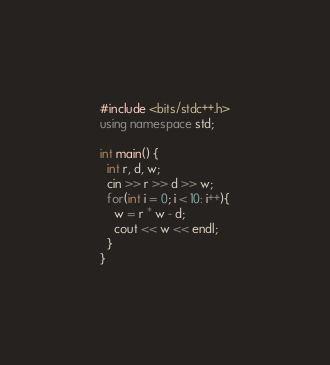Convert code to text. <code><loc_0><loc_0><loc_500><loc_500><_C++_>#include <bits/stdc++.h>
using namespace std;

int main() {
  int r, d, w;
  cin >> r >> d >> w;
  for(int i = 0; i < 10: i++){
    w = r * w - d;
    cout << w << endl;
  }
}</code> 